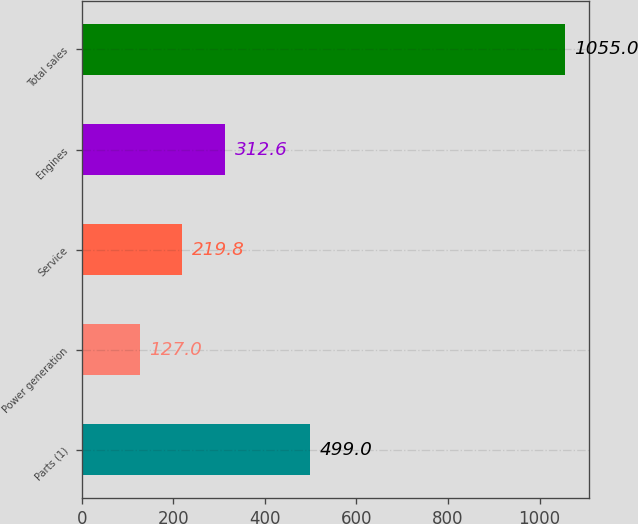Convert chart. <chart><loc_0><loc_0><loc_500><loc_500><bar_chart><fcel>Parts (1)<fcel>Power generation<fcel>Service<fcel>Engines<fcel>Total sales<nl><fcel>499<fcel>127<fcel>219.8<fcel>312.6<fcel>1055<nl></chart> 